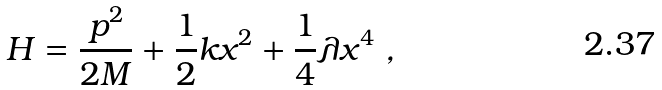<formula> <loc_0><loc_0><loc_500><loc_500>H = \frac { p ^ { 2 } } { 2 M } + \frac { 1 } { 2 } k x ^ { 2 } + \frac { 1 } { 4 } \lambda x ^ { 4 } \ ,</formula> 